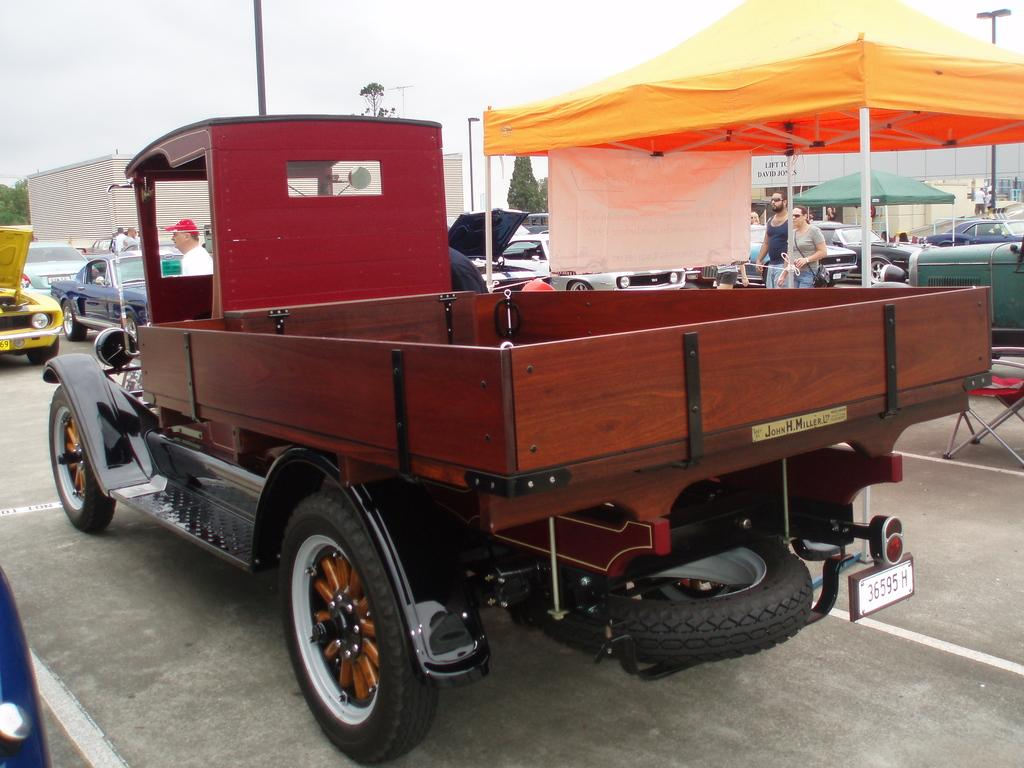What types of objects are present in the image? There are vehicles, canopy tents, poles, lights, and buildings in the image. Are there any living beings in the image? Yes, there are people in the image. What can be seen in the background of the image? The sky is visible in the background of the image. What other natural elements are present in the image? There are trees in the image. Can you see a squirrel climbing a tree in the image? There is no squirrel present in the image. What type of clam is being used as a fuel source for the vehicles in the image? There are no clams or fuel sources mentioned in the image; it features vehicles, people, canopy tents, poles, lights, and buildings. 